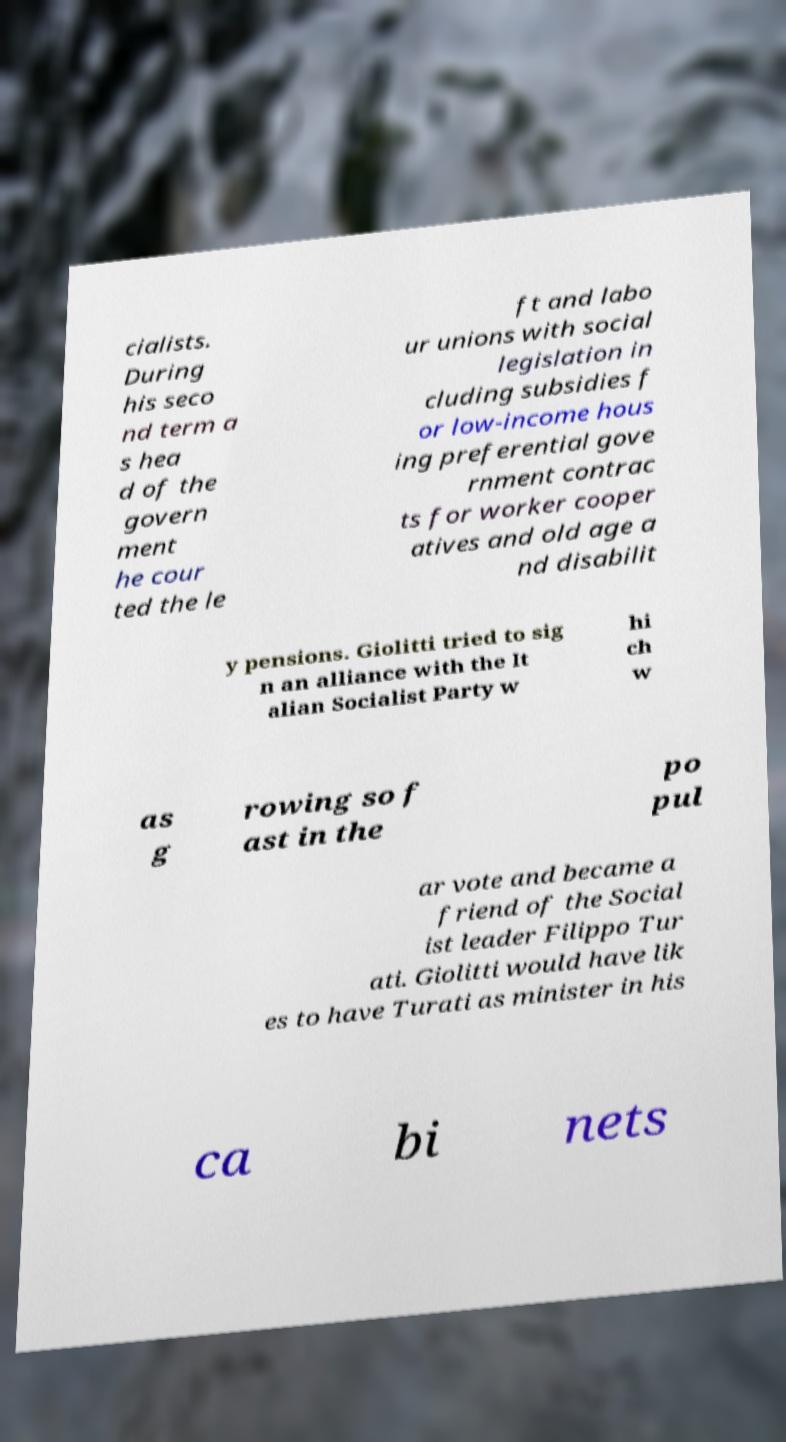Could you assist in decoding the text presented in this image and type it out clearly? cialists. During his seco nd term a s hea d of the govern ment he cour ted the le ft and labo ur unions with social legislation in cluding subsidies f or low-income hous ing preferential gove rnment contrac ts for worker cooper atives and old age a nd disabilit y pensions. Giolitti tried to sig n an alliance with the It alian Socialist Party w hi ch w as g rowing so f ast in the po pul ar vote and became a friend of the Social ist leader Filippo Tur ati. Giolitti would have lik es to have Turati as minister in his ca bi nets 